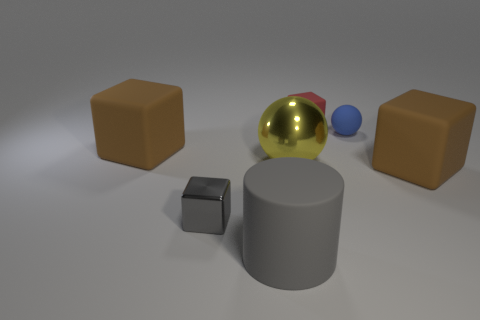Subtract all brown blocks. How many were subtracted if there are1brown blocks left? 1 Add 1 gray objects. How many objects exist? 8 Subtract all cylinders. How many objects are left? 6 Subtract all big metal spheres. Subtract all large rubber blocks. How many objects are left? 4 Add 1 small gray things. How many small gray things are left? 2 Add 5 large gray matte cylinders. How many large gray matte cylinders exist? 6 Subtract 0 red spheres. How many objects are left? 7 